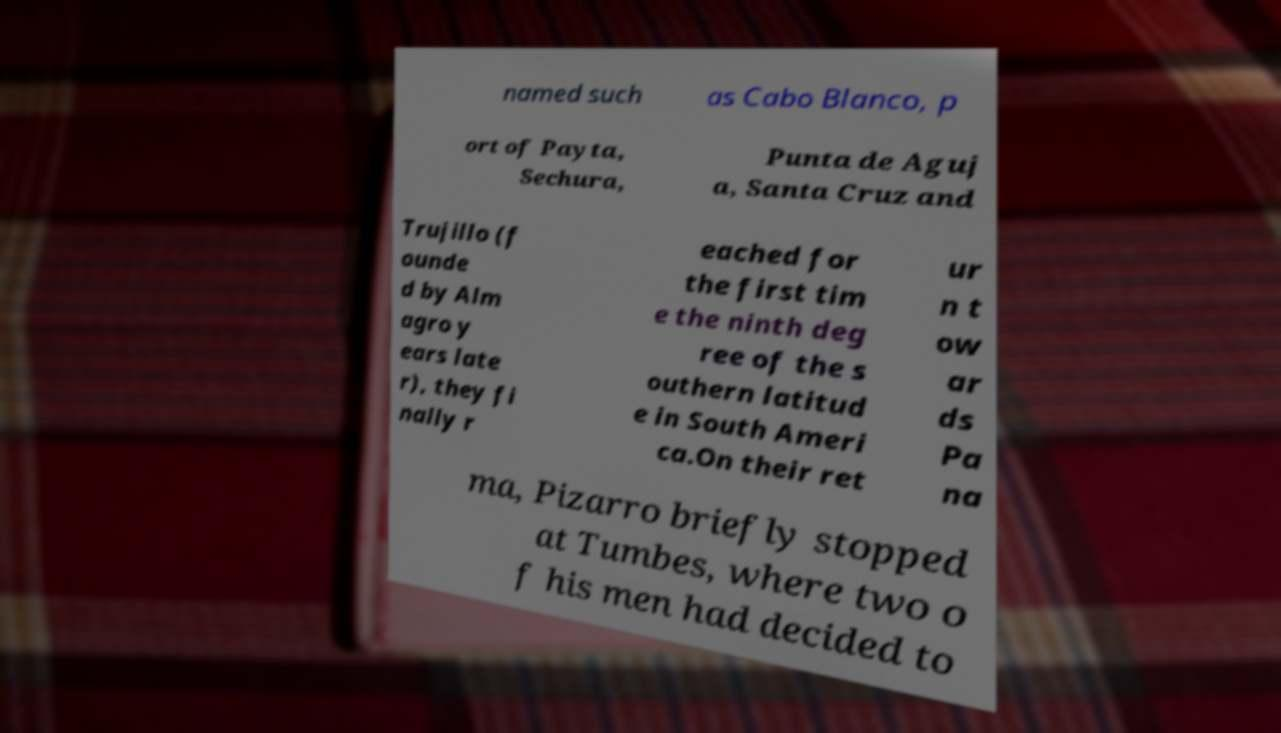Could you assist in decoding the text presented in this image and type it out clearly? named such as Cabo Blanco, p ort of Payta, Sechura, Punta de Aguj a, Santa Cruz and Trujillo (f ounde d by Alm agro y ears late r), they fi nally r eached for the first tim e the ninth deg ree of the s outhern latitud e in South Ameri ca.On their ret ur n t ow ar ds Pa na ma, Pizarro briefly stopped at Tumbes, where two o f his men had decided to 